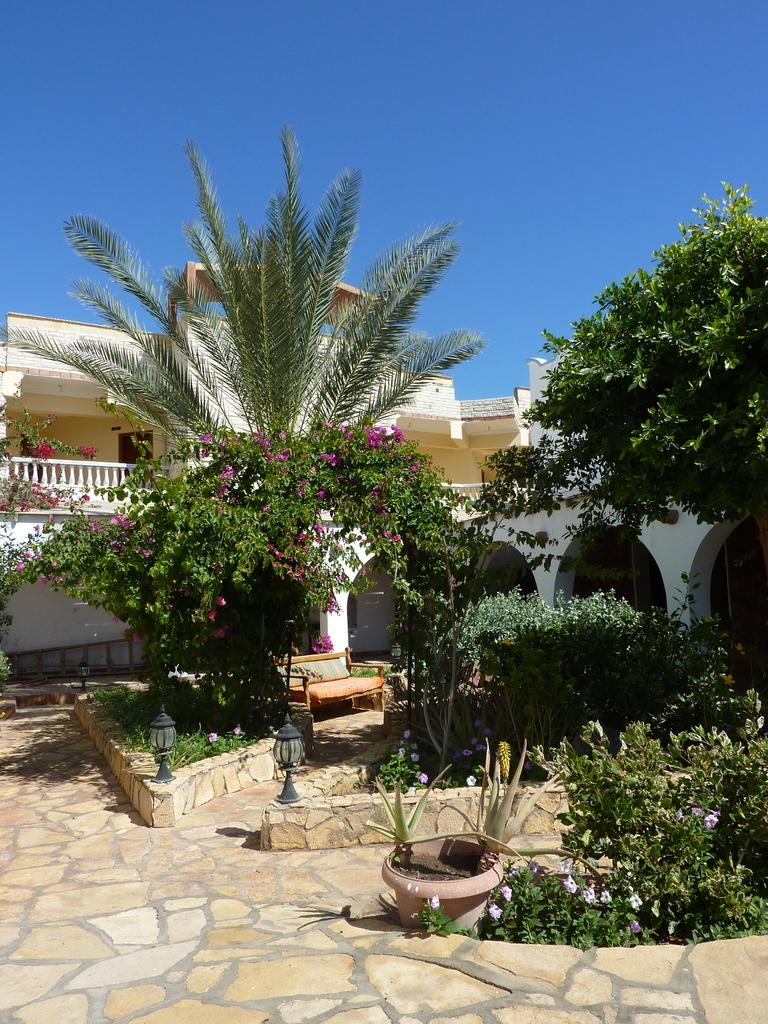What type of living organisms can be seen in the image? Plants can be seen in the image. What type of artificial light sources are present in the image? There are lights in the image. What type of seating is available in the image? There is a bench in the image. What is visible at the bottom of the image? The floor is visible at the bottom of the image. What type of vegetation is visible in the background of the image? Trees are visible in the background of the image. What type of man-made structures are visible in the background of the image? Buildings are visible in the background of the image. What part of the natural environment is visible in the background of the image? The sky is visible in the background of the image. Can you tell me how many knives are placed on the bench in the image? There are no knives present on the bench or anywhere else in the image. What type of pin is holding the lights in the image? There are no pins holding the lights in the image; they are likely attached using other methods, such as wires or brackets. 